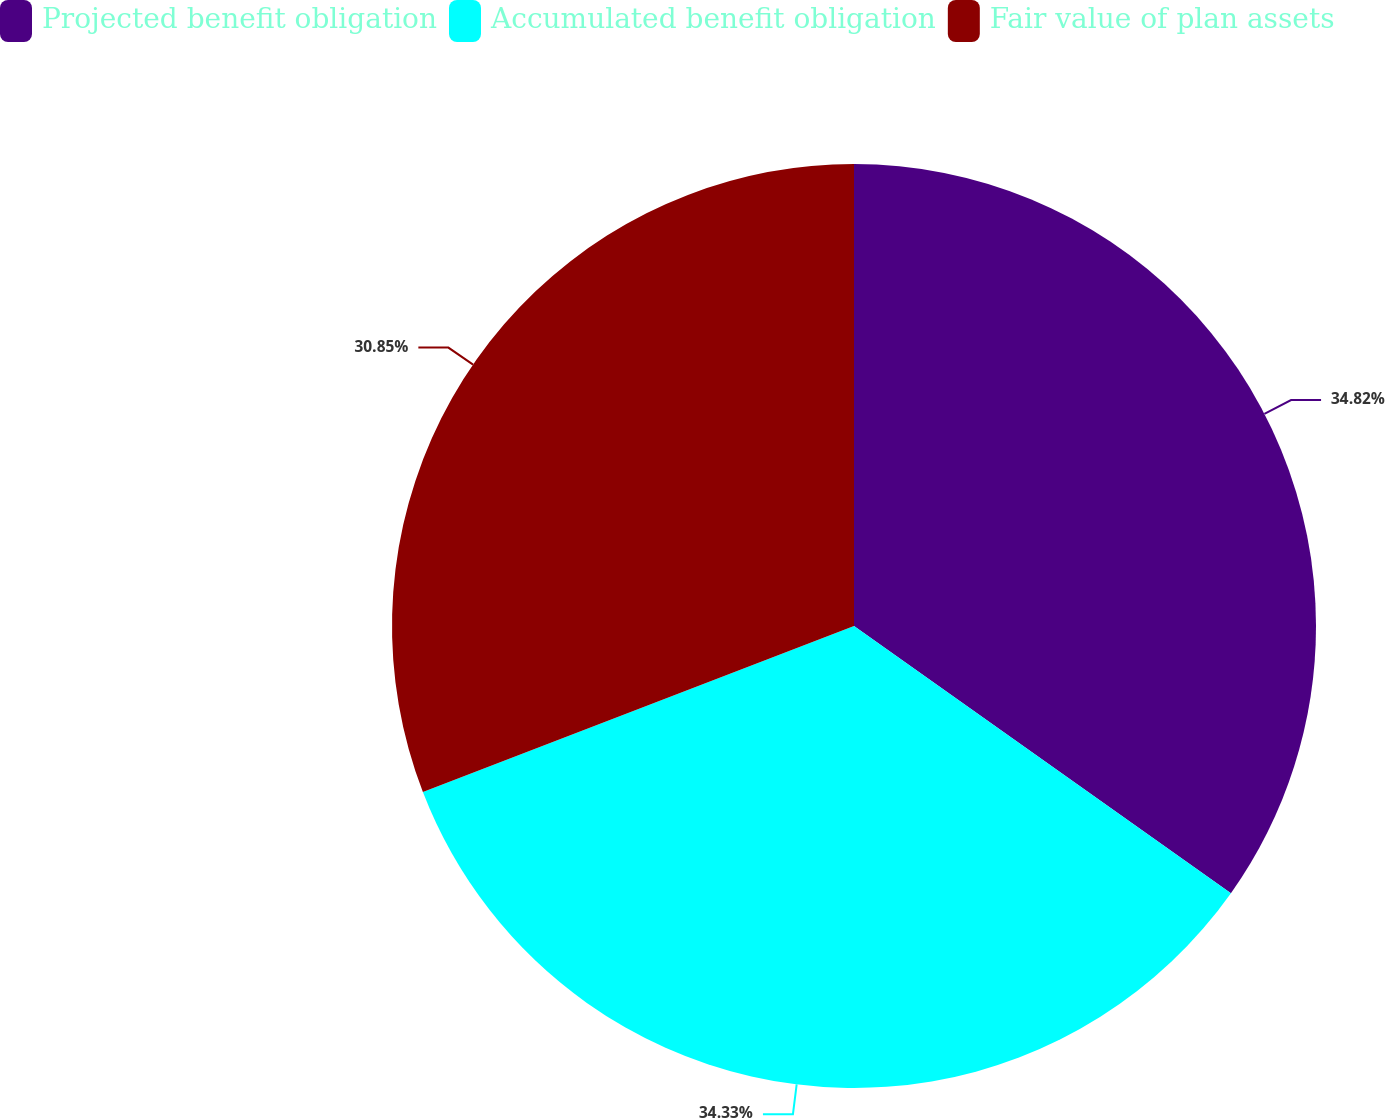<chart> <loc_0><loc_0><loc_500><loc_500><pie_chart><fcel>Projected benefit obligation<fcel>Accumulated benefit obligation<fcel>Fair value of plan assets<nl><fcel>34.81%<fcel>34.33%<fcel>30.85%<nl></chart> 